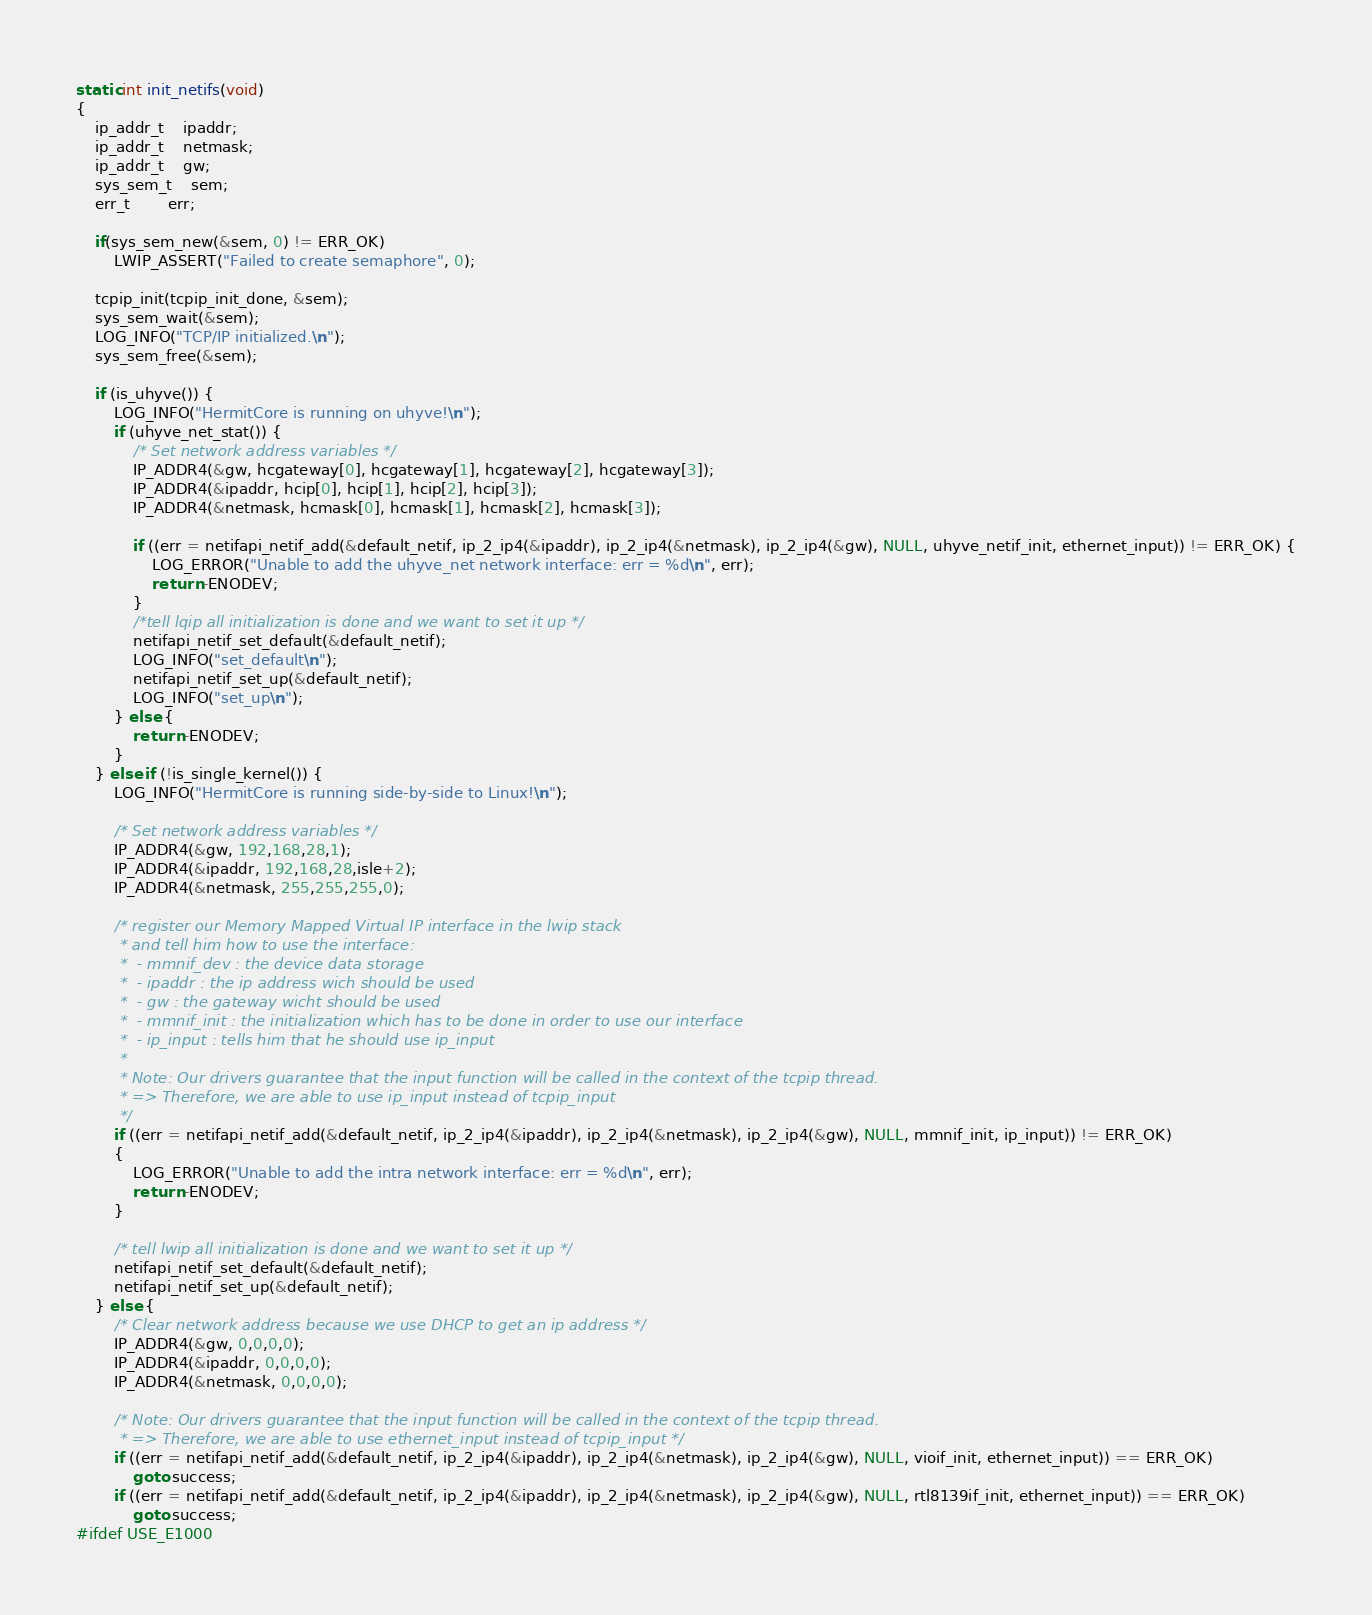Convert code to text. <code><loc_0><loc_0><loc_500><loc_500><_C_>
static int init_netifs(void)
{
	ip_addr_t	ipaddr;
	ip_addr_t	netmask;
	ip_addr_t	gw;
	sys_sem_t	sem;
	err_t		err;

	if(sys_sem_new(&sem, 0) != ERR_OK)
		LWIP_ASSERT("Failed to create semaphore", 0);

	tcpip_init(tcpip_init_done, &sem);
	sys_sem_wait(&sem);
	LOG_INFO("TCP/IP initialized.\n");
	sys_sem_free(&sem);

	if (is_uhyve()) {
		LOG_INFO("HermitCore is running on uhyve!\n");
		if (uhyve_net_stat()) {
			/* Set network address variables */
			IP_ADDR4(&gw, hcgateway[0], hcgateway[1], hcgateway[2], hcgateway[3]);
			IP_ADDR4(&ipaddr, hcip[0], hcip[1], hcip[2], hcip[3]);
			IP_ADDR4(&netmask, hcmask[0], hcmask[1], hcmask[2], hcmask[3]);

			if ((err = netifapi_netif_add(&default_netif, ip_2_ip4(&ipaddr), ip_2_ip4(&netmask), ip_2_ip4(&gw), NULL, uhyve_netif_init, ethernet_input)) != ERR_OK) {
				LOG_ERROR("Unable to add the uhyve_net network interface: err = %d\n", err);
				return -ENODEV;
			}
			/*tell lqip all initialization is done and we want to set it up */
			netifapi_netif_set_default(&default_netif);
			LOG_INFO("set_default\n");
			netifapi_netif_set_up(&default_netif);
			LOG_INFO("set_up\n");
		} else {
			return -ENODEV;
		}
	} else if (!is_single_kernel()) {
		LOG_INFO("HermitCore is running side-by-side to Linux!\n");

		/* Set network address variables */
		IP_ADDR4(&gw, 192,168,28,1);
		IP_ADDR4(&ipaddr, 192,168,28,isle+2);
		IP_ADDR4(&netmask, 255,255,255,0);

		/* register our Memory Mapped Virtual IP interface in the lwip stack
		 * and tell him how to use the interface:
		 *  - mmnif_dev : the device data storage
		 *  - ipaddr : the ip address wich should be used
		 *  - gw : the gateway wicht should be used
		 *  - mmnif_init : the initialization which has to be done in order to use our interface
		 *  - ip_input : tells him that he should use ip_input
		 *
		 * Note: Our drivers guarantee that the input function will be called in the context of the tcpip thread.
		 * => Therefore, we are able to use ip_input instead of tcpip_input
		 */
		if ((err = netifapi_netif_add(&default_netif, ip_2_ip4(&ipaddr), ip_2_ip4(&netmask), ip_2_ip4(&gw), NULL, mmnif_init, ip_input)) != ERR_OK)
		{
			LOG_ERROR("Unable to add the intra network interface: err = %d\n", err);
			return -ENODEV;
		}

		/* tell lwip all initialization is done and we want to set it up */
		netifapi_netif_set_default(&default_netif);
		netifapi_netif_set_up(&default_netif);
	} else {
		/* Clear network address because we use DHCP to get an ip address */
		IP_ADDR4(&gw, 0,0,0,0);
		IP_ADDR4(&ipaddr, 0,0,0,0);
		IP_ADDR4(&netmask, 0,0,0,0);

		/* Note: Our drivers guarantee that the input function will be called in the context of the tcpip thread.
		 * => Therefore, we are able to use ethernet_input instead of tcpip_input */
		if ((err = netifapi_netif_add(&default_netif, ip_2_ip4(&ipaddr), ip_2_ip4(&netmask), ip_2_ip4(&gw), NULL, vioif_init, ethernet_input)) == ERR_OK)
			goto success;
		if ((err = netifapi_netif_add(&default_netif, ip_2_ip4(&ipaddr), ip_2_ip4(&netmask), ip_2_ip4(&gw), NULL, rtl8139if_init, ethernet_input)) == ERR_OK)
			goto success;
#ifdef USE_E1000</code> 